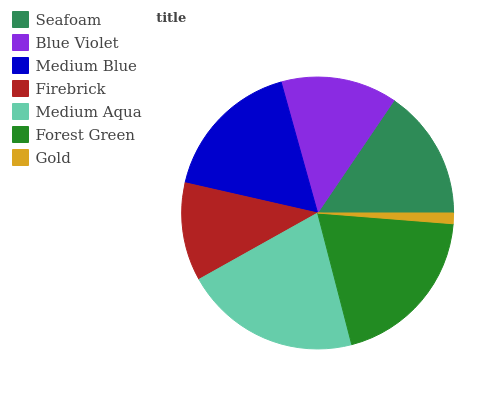Is Gold the minimum?
Answer yes or no. Yes. Is Medium Aqua the maximum?
Answer yes or no. Yes. Is Blue Violet the minimum?
Answer yes or no. No. Is Blue Violet the maximum?
Answer yes or no. No. Is Seafoam greater than Blue Violet?
Answer yes or no. Yes. Is Blue Violet less than Seafoam?
Answer yes or no. Yes. Is Blue Violet greater than Seafoam?
Answer yes or no. No. Is Seafoam less than Blue Violet?
Answer yes or no. No. Is Seafoam the high median?
Answer yes or no. Yes. Is Seafoam the low median?
Answer yes or no. Yes. Is Forest Green the high median?
Answer yes or no. No. Is Gold the low median?
Answer yes or no. No. 